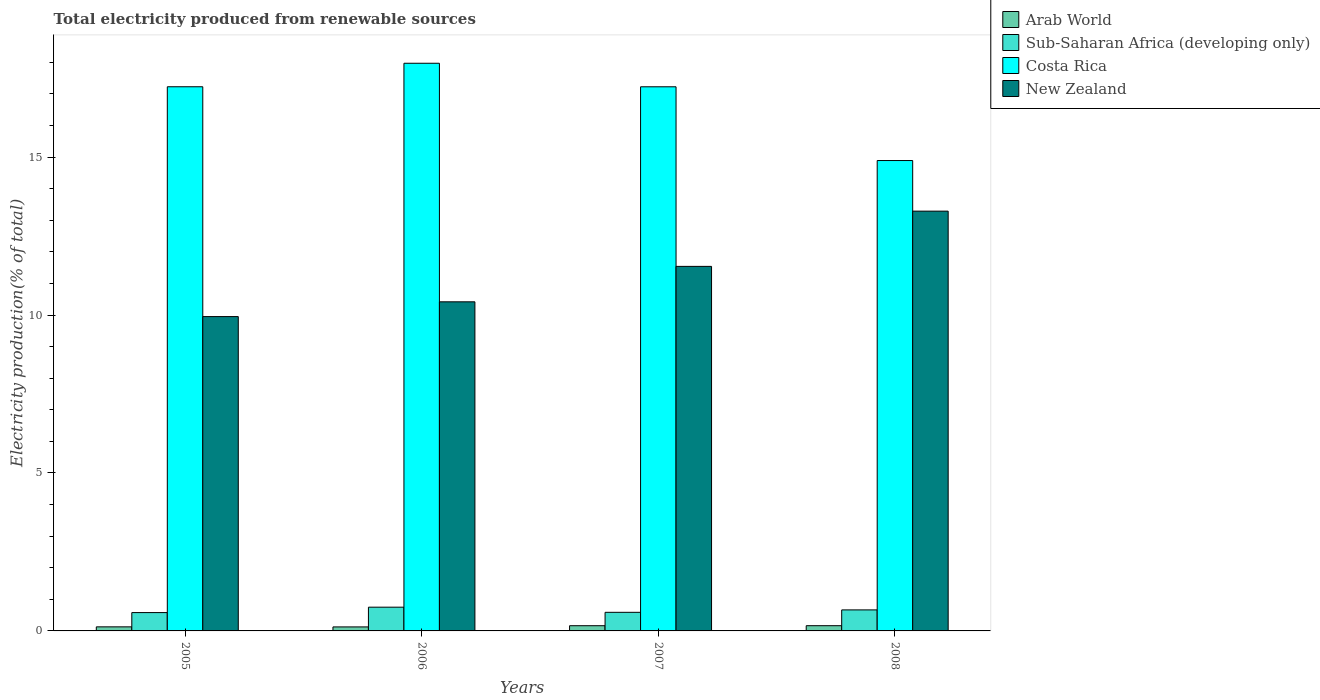How many groups of bars are there?
Your answer should be compact. 4. Are the number of bars per tick equal to the number of legend labels?
Your response must be concise. Yes. How many bars are there on the 1st tick from the left?
Provide a succinct answer. 4. What is the total electricity produced in Sub-Saharan Africa (developing only) in 2006?
Provide a short and direct response. 0.75. Across all years, what is the maximum total electricity produced in Arab World?
Keep it short and to the point. 0.17. Across all years, what is the minimum total electricity produced in Sub-Saharan Africa (developing only)?
Provide a short and direct response. 0.58. In which year was the total electricity produced in Sub-Saharan Africa (developing only) minimum?
Provide a succinct answer. 2005. What is the total total electricity produced in Arab World in the graph?
Provide a succinct answer. 0.59. What is the difference between the total electricity produced in Sub-Saharan Africa (developing only) in 2006 and that in 2007?
Provide a succinct answer. 0.16. What is the difference between the total electricity produced in Costa Rica in 2007 and the total electricity produced in New Zealand in 2006?
Give a very brief answer. 6.81. What is the average total electricity produced in Costa Rica per year?
Provide a short and direct response. 16.83. In the year 2006, what is the difference between the total electricity produced in New Zealand and total electricity produced in Arab World?
Provide a short and direct response. 10.29. In how many years, is the total electricity produced in Arab World greater than 6 %?
Ensure brevity in your answer.  0. What is the ratio of the total electricity produced in Arab World in 2006 to that in 2008?
Your answer should be compact. 0.77. Is the total electricity produced in Arab World in 2006 less than that in 2007?
Give a very brief answer. Yes. What is the difference between the highest and the second highest total electricity produced in Costa Rica?
Your answer should be very brief. 0.74. What is the difference between the highest and the lowest total electricity produced in Sub-Saharan Africa (developing only)?
Make the answer very short. 0.17. Is the sum of the total electricity produced in Sub-Saharan Africa (developing only) in 2005 and 2008 greater than the maximum total electricity produced in Arab World across all years?
Provide a short and direct response. Yes. Is it the case that in every year, the sum of the total electricity produced in Costa Rica and total electricity produced in Sub-Saharan Africa (developing only) is greater than the sum of total electricity produced in New Zealand and total electricity produced in Arab World?
Make the answer very short. Yes. What does the 1st bar from the left in 2006 represents?
Your answer should be very brief. Arab World. What does the 4th bar from the right in 2008 represents?
Keep it short and to the point. Arab World. Is it the case that in every year, the sum of the total electricity produced in Sub-Saharan Africa (developing only) and total electricity produced in Arab World is greater than the total electricity produced in New Zealand?
Your answer should be very brief. No. Does the graph contain grids?
Provide a succinct answer. No. What is the title of the graph?
Make the answer very short. Total electricity produced from renewable sources. Does "Honduras" appear as one of the legend labels in the graph?
Keep it short and to the point. No. What is the Electricity production(% of total) in Arab World in 2005?
Your answer should be very brief. 0.13. What is the Electricity production(% of total) in Sub-Saharan Africa (developing only) in 2005?
Keep it short and to the point. 0.58. What is the Electricity production(% of total) in Costa Rica in 2005?
Your answer should be compact. 17.23. What is the Electricity production(% of total) in New Zealand in 2005?
Offer a terse response. 9.95. What is the Electricity production(% of total) of Arab World in 2006?
Your answer should be very brief. 0.13. What is the Electricity production(% of total) of Sub-Saharan Africa (developing only) in 2006?
Your answer should be compact. 0.75. What is the Electricity production(% of total) in Costa Rica in 2006?
Your answer should be very brief. 17.97. What is the Electricity production(% of total) of New Zealand in 2006?
Ensure brevity in your answer.  10.42. What is the Electricity production(% of total) of Arab World in 2007?
Ensure brevity in your answer.  0.16. What is the Electricity production(% of total) in Sub-Saharan Africa (developing only) in 2007?
Offer a terse response. 0.59. What is the Electricity production(% of total) of Costa Rica in 2007?
Offer a terse response. 17.23. What is the Electricity production(% of total) in New Zealand in 2007?
Your answer should be compact. 11.54. What is the Electricity production(% of total) of Arab World in 2008?
Ensure brevity in your answer.  0.17. What is the Electricity production(% of total) in Sub-Saharan Africa (developing only) in 2008?
Ensure brevity in your answer.  0.67. What is the Electricity production(% of total) in Costa Rica in 2008?
Make the answer very short. 14.89. What is the Electricity production(% of total) of New Zealand in 2008?
Ensure brevity in your answer.  13.29. Across all years, what is the maximum Electricity production(% of total) in Arab World?
Offer a terse response. 0.17. Across all years, what is the maximum Electricity production(% of total) of Sub-Saharan Africa (developing only)?
Make the answer very short. 0.75. Across all years, what is the maximum Electricity production(% of total) in Costa Rica?
Give a very brief answer. 17.97. Across all years, what is the maximum Electricity production(% of total) of New Zealand?
Offer a terse response. 13.29. Across all years, what is the minimum Electricity production(% of total) of Arab World?
Provide a succinct answer. 0.13. Across all years, what is the minimum Electricity production(% of total) in Sub-Saharan Africa (developing only)?
Ensure brevity in your answer.  0.58. Across all years, what is the minimum Electricity production(% of total) in Costa Rica?
Make the answer very short. 14.89. Across all years, what is the minimum Electricity production(% of total) of New Zealand?
Keep it short and to the point. 9.95. What is the total Electricity production(% of total) of Arab World in the graph?
Your response must be concise. 0.59. What is the total Electricity production(% of total) of Sub-Saharan Africa (developing only) in the graph?
Offer a terse response. 2.59. What is the total Electricity production(% of total) of Costa Rica in the graph?
Provide a succinct answer. 67.32. What is the total Electricity production(% of total) in New Zealand in the graph?
Offer a terse response. 45.2. What is the difference between the Electricity production(% of total) in Arab World in 2005 and that in 2006?
Make the answer very short. 0. What is the difference between the Electricity production(% of total) in Sub-Saharan Africa (developing only) in 2005 and that in 2006?
Keep it short and to the point. -0.17. What is the difference between the Electricity production(% of total) in Costa Rica in 2005 and that in 2006?
Ensure brevity in your answer.  -0.74. What is the difference between the Electricity production(% of total) in New Zealand in 2005 and that in 2006?
Give a very brief answer. -0.47. What is the difference between the Electricity production(% of total) of Arab World in 2005 and that in 2007?
Provide a succinct answer. -0.04. What is the difference between the Electricity production(% of total) of Sub-Saharan Africa (developing only) in 2005 and that in 2007?
Your answer should be very brief. -0.01. What is the difference between the Electricity production(% of total) in Costa Rica in 2005 and that in 2007?
Your answer should be very brief. 0. What is the difference between the Electricity production(% of total) of New Zealand in 2005 and that in 2007?
Provide a succinct answer. -1.59. What is the difference between the Electricity production(% of total) in Arab World in 2005 and that in 2008?
Offer a terse response. -0.04. What is the difference between the Electricity production(% of total) of Sub-Saharan Africa (developing only) in 2005 and that in 2008?
Ensure brevity in your answer.  -0.09. What is the difference between the Electricity production(% of total) in Costa Rica in 2005 and that in 2008?
Offer a terse response. 2.34. What is the difference between the Electricity production(% of total) of New Zealand in 2005 and that in 2008?
Your answer should be compact. -3.34. What is the difference between the Electricity production(% of total) of Arab World in 2006 and that in 2007?
Provide a short and direct response. -0.04. What is the difference between the Electricity production(% of total) in Sub-Saharan Africa (developing only) in 2006 and that in 2007?
Provide a short and direct response. 0.16. What is the difference between the Electricity production(% of total) of Costa Rica in 2006 and that in 2007?
Your answer should be compact. 0.75. What is the difference between the Electricity production(% of total) in New Zealand in 2006 and that in 2007?
Ensure brevity in your answer.  -1.12. What is the difference between the Electricity production(% of total) in Arab World in 2006 and that in 2008?
Your answer should be very brief. -0.04. What is the difference between the Electricity production(% of total) in Sub-Saharan Africa (developing only) in 2006 and that in 2008?
Provide a succinct answer. 0.09. What is the difference between the Electricity production(% of total) of Costa Rica in 2006 and that in 2008?
Provide a short and direct response. 3.08. What is the difference between the Electricity production(% of total) in New Zealand in 2006 and that in 2008?
Give a very brief answer. -2.87. What is the difference between the Electricity production(% of total) in Arab World in 2007 and that in 2008?
Keep it short and to the point. -0. What is the difference between the Electricity production(% of total) in Sub-Saharan Africa (developing only) in 2007 and that in 2008?
Your answer should be compact. -0.08. What is the difference between the Electricity production(% of total) of Costa Rica in 2007 and that in 2008?
Provide a succinct answer. 2.33. What is the difference between the Electricity production(% of total) in New Zealand in 2007 and that in 2008?
Your response must be concise. -1.75. What is the difference between the Electricity production(% of total) in Arab World in 2005 and the Electricity production(% of total) in Sub-Saharan Africa (developing only) in 2006?
Provide a short and direct response. -0.62. What is the difference between the Electricity production(% of total) of Arab World in 2005 and the Electricity production(% of total) of Costa Rica in 2006?
Ensure brevity in your answer.  -17.84. What is the difference between the Electricity production(% of total) in Arab World in 2005 and the Electricity production(% of total) in New Zealand in 2006?
Provide a succinct answer. -10.29. What is the difference between the Electricity production(% of total) in Sub-Saharan Africa (developing only) in 2005 and the Electricity production(% of total) in Costa Rica in 2006?
Keep it short and to the point. -17.39. What is the difference between the Electricity production(% of total) in Sub-Saharan Africa (developing only) in 2005 and the Electricity production(% of total) in New Zealand in 2006?
Provide a succinct answer. -9.84. What is the difference between the Electricity production(% of total) in Costa Rica in 2005 and the Electricity production(% of total) in New Zealand in 2006?
Keep it short and to the point. 6.81. What is the difference between the Electricity production(% of total) in Arab World in 2005 and the Electricity production(% of total) in Sub-Saharan Africa (developing only) in 2007?
Offer a very short reply. -0.46. What is the difference between the Electricity production(% of total) of Arab World in 2005 and the Electricity production(% of total) of Costa Rica in 2007?
Your answer should be compact. -17.1. What is the difference between the Electricity production(% of total) in Arab World in 2005 and the Electricity production(% of total) in New Zealand in 2007?
Your answer should be very brief. -11.41. What is the difference between the Electricity production(% of total) of Sub-Saharan Africa (developing only) in 2005 and the Electricity production(% of total) of Costa Rica in 2007?
Your response must be concise. -16.65. What is the difference between the Electricity production(% of total) in Sub-Saharan Africa (developing only) in 2005 and the Electricity production(% of total) in New Zealand in 2007?
Make the answer very short. -10.96. What is the difference between the Electricity production(% of total) of Costa Rica in 2005 and the Electricity production(% of total) of New Zealand in 2007?
Provide a short and direct response. 5.69. What is the difference between the Electricity production(% of total) of Arab World in 2005 and the Electricity production(% of total) of Sub-Saharan Africa (developing only) in 2008?
Keep it short and to the point. -0.54. What is the difference between the Electricity production(% of total) in Arab World in 2005 and the Electricity production(% of total) in Costa Rica in 2008?
Your answer should be compact. -14.76. What is the difference between the Electricity production(% of total) in Arab World in 2005 and the Electricity production(% of total) in New Zealand in 2008?
Ensure brevity in your answer.  -13.16. What is the difference between the Electricity production(% of total) in Sub-Saharan Africa (developing only) in 2005 and the Electricity production(% of total) in Costa Rica in 2008?
Ensure brevity in your answer.  -14.31. What is the difference between the Electricity production(% of total) of Sub-Saharan Africa (developing only) in 2005 and the Electricity production(% of total) of New Zealand in 2008?
Provide a short and direct response. -12.71. What is the difference between the Electricity production(% of total) of Costa Rica in 2005 and the Electricity production(% of total) of New Zealand in 2008?
Offer a very short reply. 3.94. What is the difference between the Electricity production(% of total) in Arab World in 2006 and the Electricity production(% of total) in Sub-Saharan Africa (developing only) in 2007?
Ensure brevity in your answer.  -0.46. What is the difference between the Electricity production(% of total) in Arab World in 2006 and the Electricity production(% of total) in Costa Rica in 2007?
Provide a succinct answer. -17.1. What is the difference between the Electricity production(% of total) of Arab World in 2006 and the Electricity production(% of total) of New Zealand in 2007?
Provide a short and direct response. -11.41. What is the difference between the Electricity production(% of total) of Sub-Saharan Africa (developing only) in 2006 and the Electricity production(% of total) of Costa Rica in 2007?
Make the answer very short. -16.48. What is the difference between the Electricity production(% of total) of Sub-Saharan Africa (developing only) in 2006 and the Electricity production(% of total) of New Zealand in 2007?
Your answer should be compact. -10.79. What is the difference between the Electricity production(% of total) in Costa Rica in 2006 and the Electricity production(% of total) in New Zealand in 2007?
Provide a short and direct response. 6.43. What is the difference between the Electricity production(% of total) of Arab World in 2006 and the Electricity production(% of total) of Sub-Saharan Africa (developing only) in 2008?
Ensure brevity in your answer.  -0.54. What is the difference between the Electricity production(% of total) in Arab World in 2006 and the Electricity production(% of total) in Costa Rica in 2008?
Make the answer very short. -14.76. What is the difference between the Electricity production(% of total) in Arab World in 2006 and the Electricity production(% of total) in New Zealand in 2008?
Provide a short and direct response. -13.16. What is the difference between the Electricity production(% of total) in Sub-Saharan Africa (developing only) in 2006 and the Electricity production(% of total) in Costa Rica in 2008?
Provide a short and direct response. -14.14. What is the difference between the Electricity production(% of total) in Sub-Saharan Africa (developing only) in 2006 and the Electricity production(% of total) in New Zealand in 2008?
Your response must be concise. -12.54. What is the difference between the Electricity production(% of total) of Costa Rica in 2006 and the Electricity production(% of total) of New Zealand in 2008?
Your answer should be very brief. 4.68. What is the difference between the Electricity production(% of total) in Arab World in 2007 and the Electricity production(% of total) in Sub-Saharan Africa (developing only) in 2008?
Your answer should be compact. -0.5. What is the difference between the Electricity production(% of total) in Arab World in 2007 and the Electricity production(% of total) in Costa Rica in 2008?
Ensure brevity in your answer.  -14.73. What is the difference between the Electricity production(% of total) of Arab World in 2007 and the Electricity production(% of total) of New Zealand in 2008?
Your answer should be compact. -13.13. What is the difference between the Electricity production(% of total) of Sub-Saharan Africa (developing only) in 2007 and the Electricity production(% of total) of Costa Rica in 2008?
Provide a succinct answer. -14.3. What is the difference between the Electricity production(% of total) in Sub-Saharan Africa (developing only) in 2007 and the Electricity production(% of total) in New Zealand in 2008?
Offer a very short reply. -12.7. What is the difference between the Electricity production(% of total) of Costa Rica in 2007 and the Electricity production(% of total) of New Zealand in 2008?
Provide a short and direct response. 3.94. What is the average Electricity production(% of total) in Arab World per year?
Ensure brevity in your answer.  0.15. What is the average Electricity production(% of total) of Sub-Saharan Africa (developing only) per year?
Offer a terse response. 0.65. What is the average Electricity production(% of total) in Costa Rica per year?
Your response must be concise. 16.83. What is the average Electricity production(% of total) in New Zealand per year?
Keep it short and to the point. 11.3. In the year 2005, what is the difference between the Electricity production(% of total) in Arab World and Electricity production(% of total) in Sub-Saharan Africa (developing only)?
Keep it short and to the point. -0.45. In the year 2005, what is the difference between the Electricity production(% of total) in Arab World and Electricity production(% of total) in Costa Rica?
Give a very brief answer. -17.1. In the year 2005, what is the difference between the Electricity production(% of total) of Arab World and Electricity production(% of total) of New Zealand?
Provide a succinct answer. -9.82. In the year 2005, what is the difference between the Electricity production(% of total) in Sub-Saharan Africa (developing only) and Electricity production(% of total) in Costa Rica?
Your answer should be very brief. -16.65. In the year 2005, what is the difference between the Electricity production(% of total) of Sub-Saharan Africa (developing only) and Electricity production(% of total) of New Zealand?
Provide a succinct answer. -9.37. In the year 2005, what is the difference between the Electricity production(% of total) in Costa Rica and Electricity production(% of total) in New Zealand?
Provide a short and direct response. 7.28. In the year 2006, what is the difference between the Electricity production(% of total) of Arab World and Electricity production(% of total) of Sub-Saharan Africa (developing only)?
Give a very brief answer. -0.62. In the year 2006, what is the difference between the Electricity production(% of total) in Arab World and Electricity production(% of total) in Costa Rica?
Ensure brevity in your answer.  -17.84. In the year 2006, what is the difference between the Electricity production(% of total) in Arab World and Electricity production(% of total) in New Zealand?
Ensure brevity in your answer.  -10.29. In the year 2006, what is the difference between the Electricity production(% of total) of Sub-Saharan Africa (developing only) and Electricity production(% of total) of Costa Rica?
Provide a short and direct response. -17.22. In the year 2006, what is the difference between the Electricity production(% of total) of Sub-Saharan Africa (developing only) and Electricity production(% of total) of New Zealand?
Ensure brevity in your answer.  -9.67. In the year 2006, what is the difference between the Electricity production(% of total) in Costa Rica and Electricity production(% of total) in New Zealand?
Offer a very short reply. 7.55. In the year 2007, what is the difference between the Electricity production(% of total) in Arab World and Electricity production(% of total) in Sub-Saharan Africa (developing only)?
Make the answer very short. -0.42. In the year 2007, what is the difference between the Electricity production(% of total) of Arab World and Electricity production(% of total) of Costa Rica?
Your response must be concise. -17.06. In the year 2007, what is the difference between the Electricity production(% of total) of Arab World and Electricity production(% of total) of New Zealand?
Keep it short and to the point. -11.38. In the year 2007, what is the difference between the Electricity production(% of total) of Sub-Saharan Africa (developing only) and Electricity production(% of total) of Costa Rica?
Keep it short and to the point. -16.64. In the year 2007, what is the difference between the Electricity production(% of total) in Sub-Saharan Africa (developing only) and Electricity production(% of total) in New Zealand?
Make the answer very short. -10.95. In the year 2007, what is the difference between the Electricity production(% of total) of Costa Rica and Electricity production(% of total) of New Zealand?
Provide a succinct answer. 5.69. In the year 2008, what is the difference between the Electricity production(% of total) of Arab World and Electricity production(% of total) of Sub-Saharan Africa (developing only)?
Your answer should be compact. -0.5. In the year 2008, what is the difference between the Electricity production(% of total) in Arab World and Electricity production(% of total) in Costa Rica?
Make the answer very short. -14.73. In the year 2008, what is the difference between the Electricity production(% of total) in Arab World and Electricity production(% of total) in New Zealand?
Provide a short and direct response. -13.12. In the year 2008, what is the difference between the Electricity production(% of total) of Sub-Saharan Africa (developing only) and Electricity production(% of total) of Costa Rica?
Offer a terse response. -14.23. In the year 2008, what is the difference between the Electricity production(% of total) in Sub-Saharan Africa (developing only) and Electricity production(% of total) in New Zealand?
Your answer should be very brief. -12.62. In the year 2008, what is the difference between the Electricity production(% of total) of Costa Rica and Electricity production(% of total) of New Zealand?
Give a very brief answer. 1.6. What is the ratio of the Electricity production(% of total) in Arab World in 2005 to that in 2006?
Provide a short and direct response. 1.02. What is the ratio of the Electricity production(% of total) of Sub-Saharan Africa (developing only) in 2005 to that in 2006?
Make the answer very short. 0.77. What is the ratio of the Electricity production(% of total) in Costa Rica in 2005 to that in 2006?
Your answer should be very brief. 0.96. What is the ratio of the Electricity production(% of total) in New Zealand in 2005 to that in 2006?
Your answer should be very brief. 0.96. What is the ratio of the Electricity production(% of total) in Arab World in 2005 to that in 2007?
Make the answer very short. 0.78. What is the ratio of the Electricity production(% of total) in Sub-Saharan Africa (developing only) in 2005 to that in 2007?
Make the answer very short. 0.99. What is the ratio of the Electricity production(% of total) of New Zealand in 2005 to that in 2007?
Keep it short and to the point. 0.86. What is the ratio of the Electricity production(% of total) of Arab World in 2005 to that in 2008?
Make the answer very short. 0.78. What is the ratio of the Electricity production(% of total) of Sub-Saharan Africa (developing only) in 2005 to that in 2008?
Make the answer very short. 0.87. What is the ratio of the Electricity production(% of total) of Costa Rica in 2005 to that in 2008?
Your response must be concise. 1.16. What is the ratio of the Electricity production(% of total) of New Zealand in 2005 to that in 2008?
Ensure brevity in your answer.  0.75. What is the ratio of the Electricity production(% of total) of Arab World in 2006 to that in 2007?
Ensure brevity in your answer.  0.77. What is the ratio of the Electricity production(% of total) in Sub-Saharan Africa (developing only) in 2006 to that in 2007?
Your answer should be compact. 1.28. What is the ratio of the Electricity production(% of total) of Costa Rica in 2006 to that in 2007?
Offer a terse response. 1.04. What is the ratio of the Electricity production(% of total) in New Zealand in 2006 to that in 2007?
Offer a terse response. 0.9. What is the ratio of the Electricity production(% of total) of Arab World in 2006 to that in 2008?
Your answer should be very brief. 0.77. What is the ratio of the Electricity production(% of total) in Sub-Saharan Africa (developing only) in 2006 to that in 2008?
Your response must be concise. 1.13. What is the ratio of the Electricity production(% of total) in Costa Rica in 2006 to that in 2008?
Make the answer very short. 1.21. What is the ratio of the Electricity production(% of total) in New Zealand in 2006 to that in 2008?
Keep it short and to the point. 0.78. What is the ratio of the Electricity production(% of total) in Sub-Saharan Africa (developing only) in 2007 to that in 2008?
Ensure brevity in your answer.  0.88. What is the ratio of the Electricity production(% of total) in Costa Rica in 2007 to that in 2008?
Your response must be concise. 1.16. What is the ratio of the Electricity production(% of total) of New Zealand in 2007 to that in 2008?
Ensure brevity in your answer.  0.87. What is the difference between the highest and the second highest Electricity production(% of total) in Sub-Saharan Africa (developing only)?
Ensure brevity in your answer.  0.09. What is the difference between the highest and the second highest Electricity production(% of total) of Costa Rica?
Your response must be concise. 0.74. What is the difference between the highest and the second highest Electricity production(% of total) of New Zealand?
Offer a terse response. 1.75. What is the difference between the highest and the lowest Electricity production(% of total) of Arab World?
Your answer should be compact. 0.04. What is the difference between the highest and the lowest Electricity production(% of total) of Sub-Saharan Africa (developing only)?
Give a very brief answer. 0.17. What is the difference between the highest and the lowest Electricity production(% of total) in Costa Rica?
Your answer should be compact. 3.08. What is the difference between the highest and the lowest Electricity production(% of total) in New Zealand?
Your answer should be very brief. 3.34. 